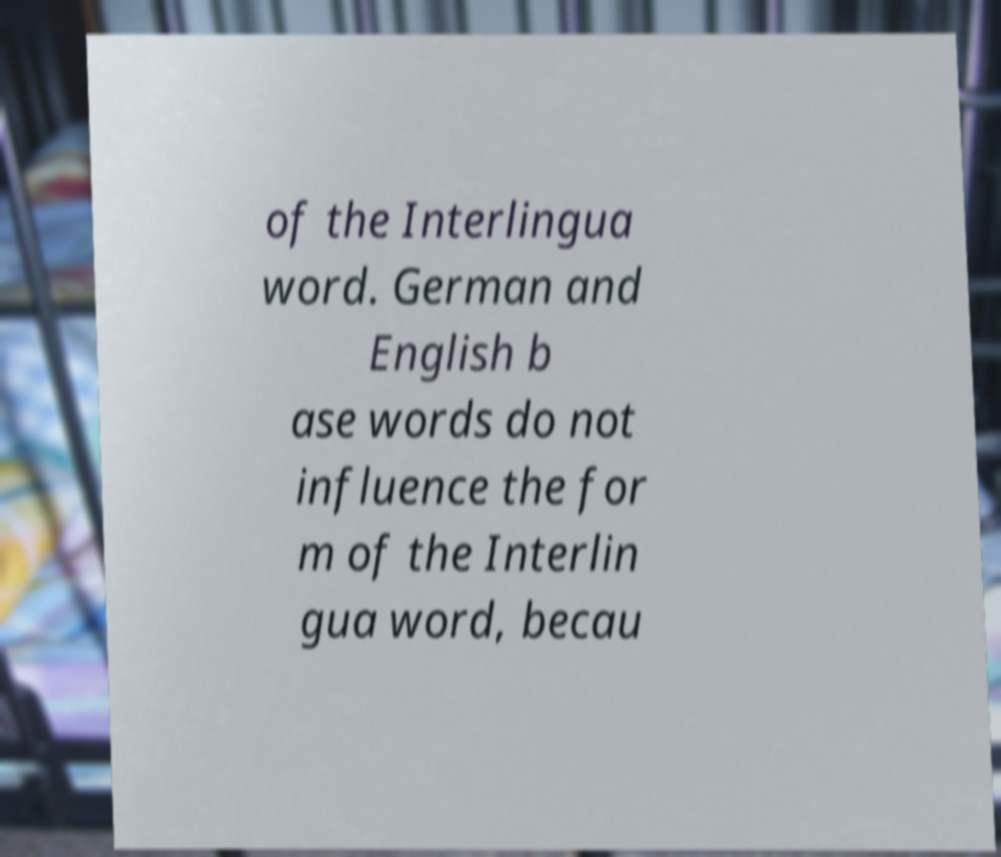Could you assist in decoding the text presented in this image and type it out clearly? of the Interlingua word. German and English b ase words do not influence the for m of the Interlin gua word, becau 